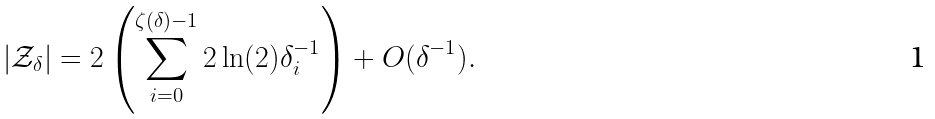Convert formula to latex. <formula><loc_0><loc_0><loc_500><loc_500>| \mathcal { Z } _ { \delta } | = 2 \left ( \sum ^ { \zeta ( \delta ) - 1 } _ { i = 0 } 2 \ln ( 2 ) \delta ^ { - 1 } _ { i } \right ) + O ( \delta ^ { - 1 } ) .</formula> 